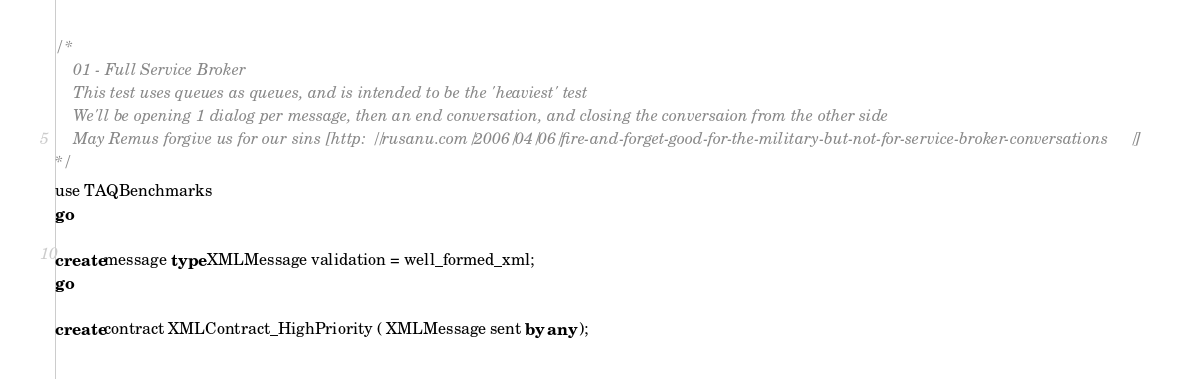<code> <loc_0><loc_0><loc_500><loc_500><_SQL_>/*
	01 - Full Service Broker
	This test uses queues as queues, and is intended to be the 'heaviest' test
	We'll be opening 1 dialog per message, then an end conversation, and closing the conversaion from the other side
	May Remus forgive us for our sins [http://rusanu.com/2006/04/06/fire-and-forget-good-for-the-military-but-not-for-service-broker-conversations/]
*/
use TAQBenchmarks
go

create message type XMLMessage validation = well_formed_xml;
go

create contract XMLContract_HighPriority ( XMLMessage sent by any );</code> 